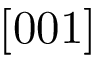Convert formula to latex. <formula><loc_0><loc_0><loc_500><loc_500>[ 0 0 1 ]</formula> 